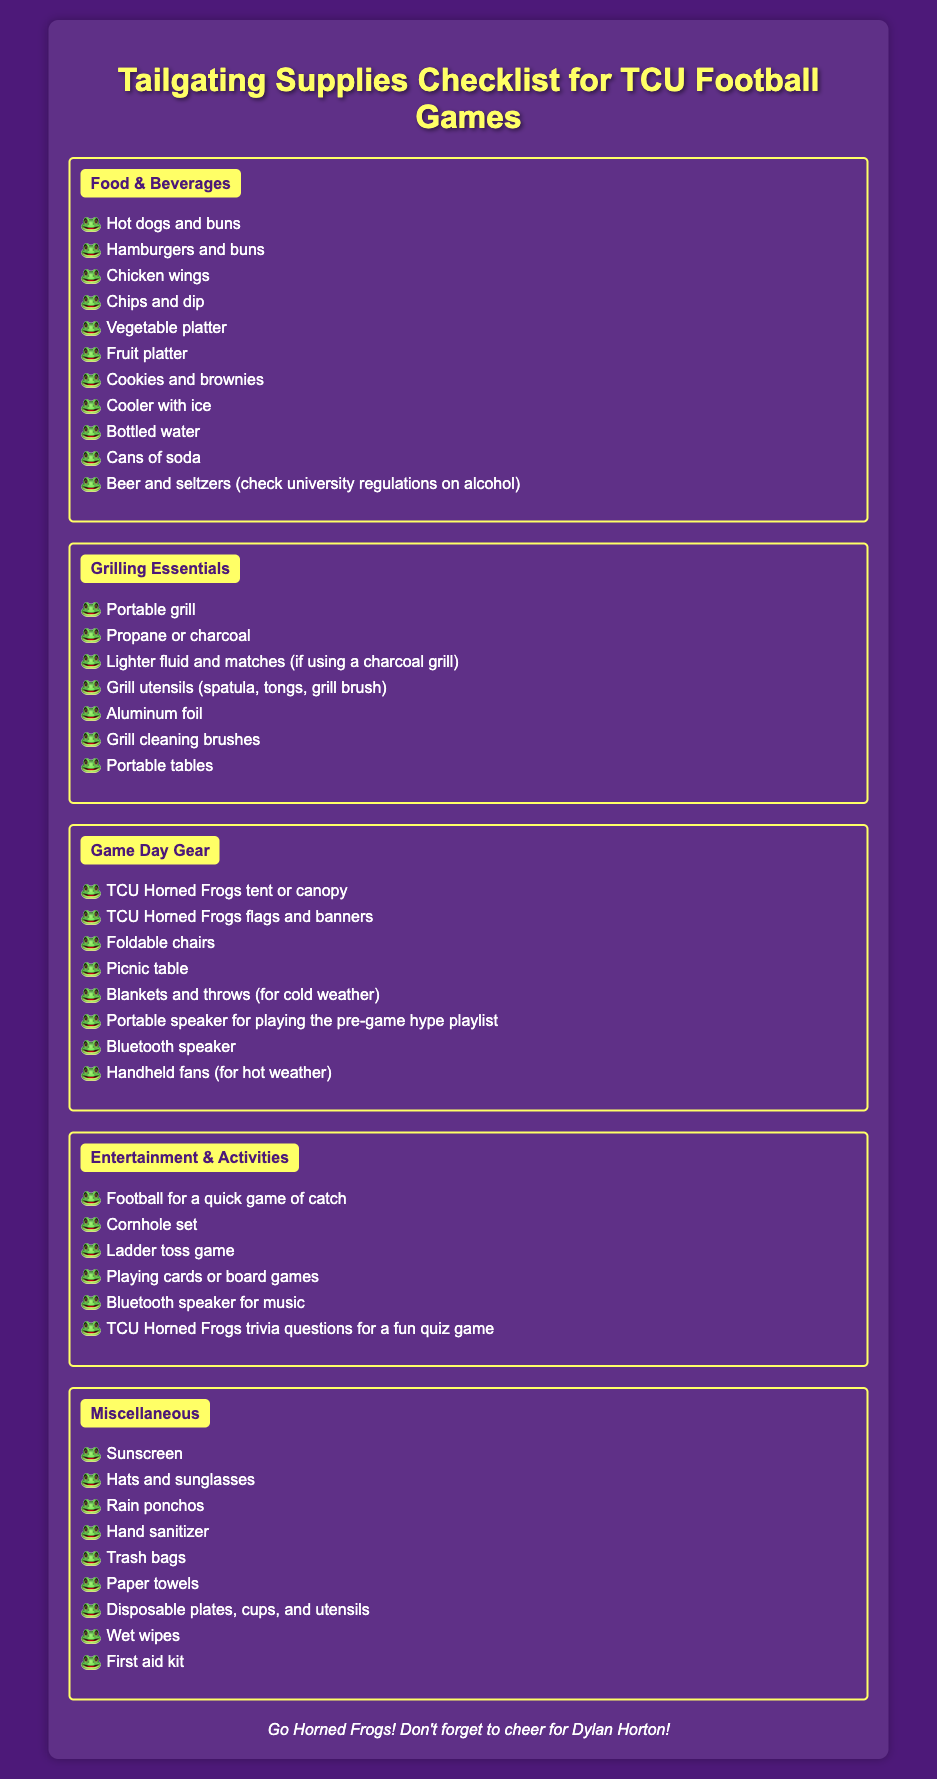What food item is mentioned first in the checklist? The first food item listed under Food & Beverages is hot dogs and buns.
Answer: Hot dogs and buns How many items are listed under Grilling Essentials? There are a total of 7 items listed under Grilling Essentials.
Answer: 7 What is included for entertainment and activities? Items such as Football for a quick game of catch and Cornhole set are included.
Answer: Football for a quick game of catch What type of speaker is mentioned twice in the document? Both a portable speaker and a Bluetooth speaker are mentioned for playing music or pre-game playlists.
Answer: Bluetooth speaker How many sections are there in the checklist? There are a total of 5 sections listed in the checklist.
Answer: 5 What should you bring if it's cold weather? The item to bring for cold weather is blankets and throws.
Answer: Blankets and throws Is there a first aid kit included in the miscellaneous section? Yes, there is a first aid kit listed under Miscellaneous.
Answer: Yes What color is the background of the document? The background color of the document is TCU purple.
Answer: TCU purple 